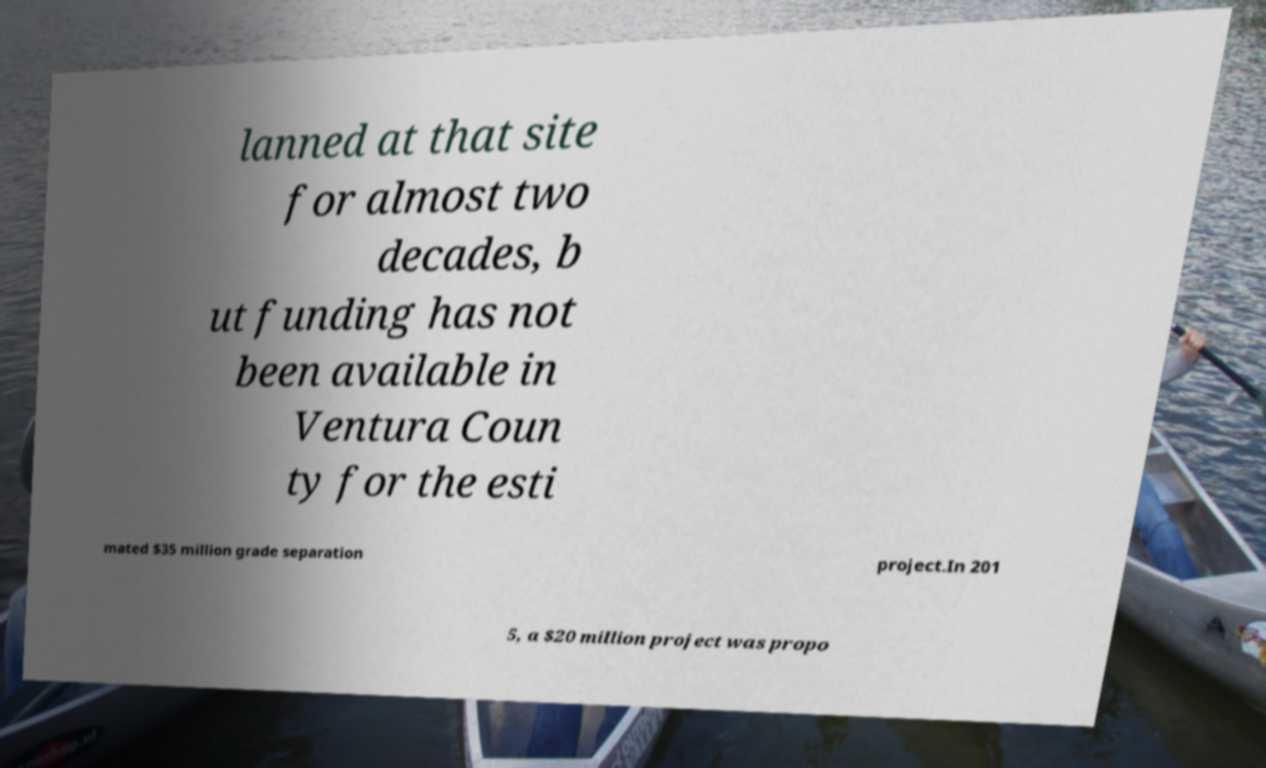What messages or text are displayed in this image? I need them in a readable, typed format. lanned at that site for almost two decades, b ut funding has not been available in Ventura Coun ty for the esti mated $35 million grade separation project.In 201 5, a $20 million project was propo 